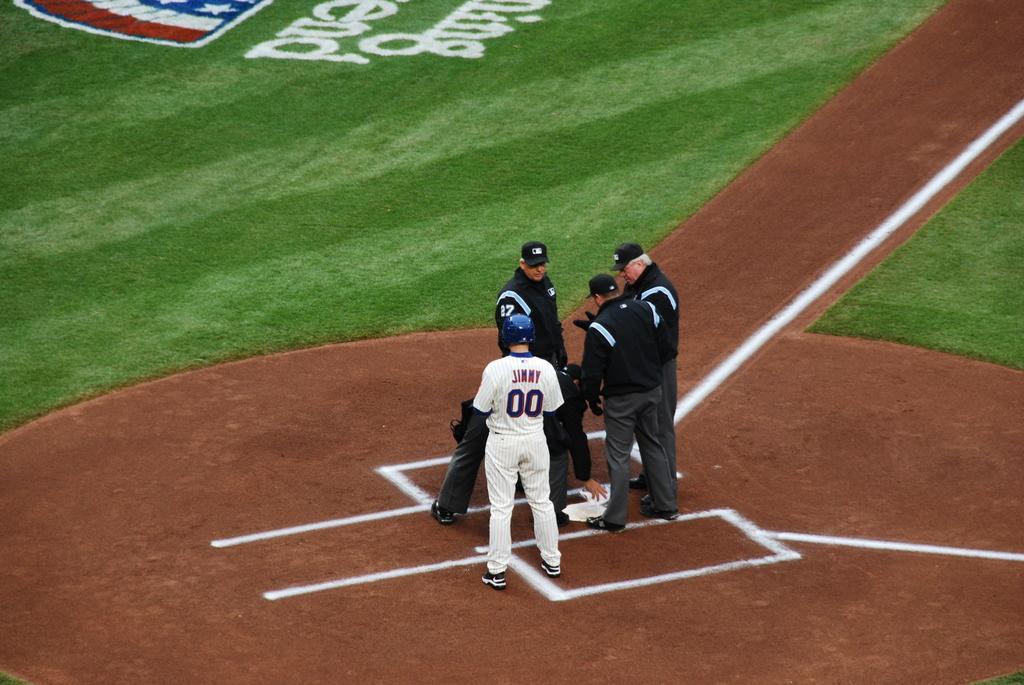Can you describe this image briefly? In this picture we can see a group of people standing on the ground and in front of the people there is grass. 